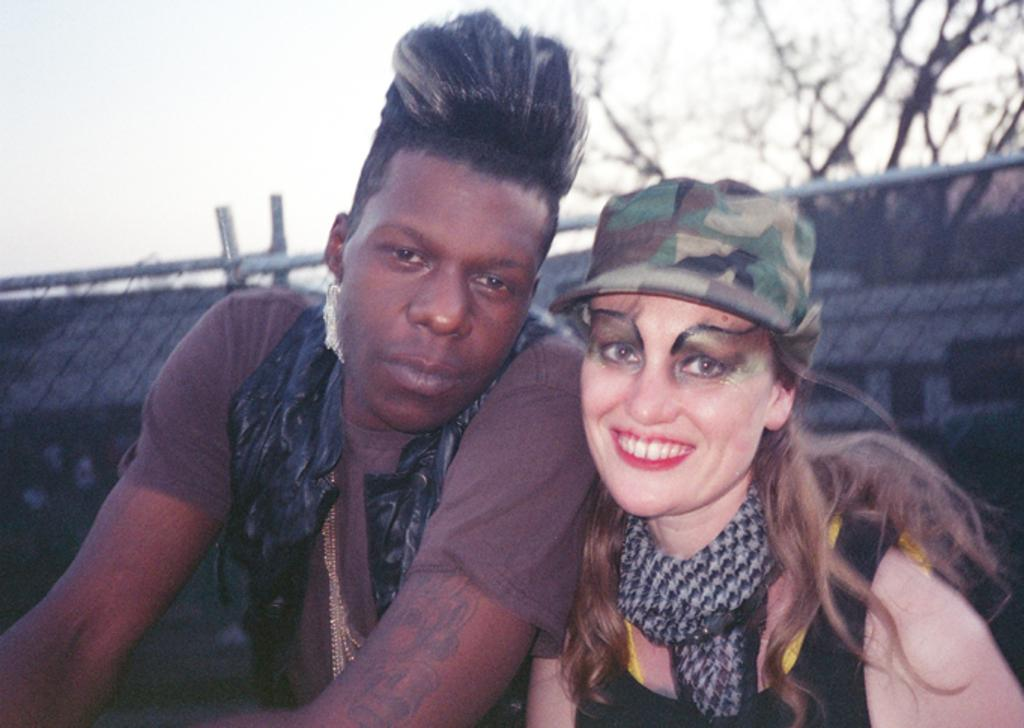How many people are visible in the image? There are two people in the front of the image. What can be seen in the background of the image? There is a fence and a tree in the image. What is visible at the top of the image? The sky is visible at the top of the image. What type of stew is being prepared by the grandmother in the image? There is no grandmother or stew present in the image. 